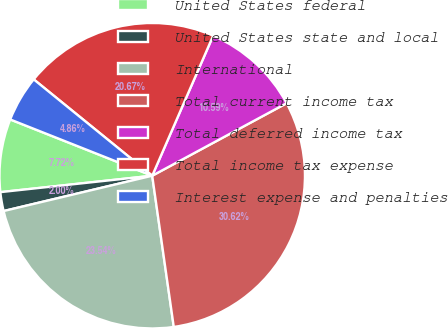Convert chart to OTSL. <chart><loc_0><loc_0><loc_500><loc_500><pie_chart><fcel>United States federal<fcel>United States state and local<fcel>International<fcel>Total current income tax<fcel>Total deferred income tax<fcel>Total income tax expense<fcel>Interest expense and penalties<nl><fcel>7.72%<fcel>2.0%<fcel>23.54%<fcel>30.62%<fcel>10.59%<fcel>20.67%<fcel>4.86%<nl></chart> 